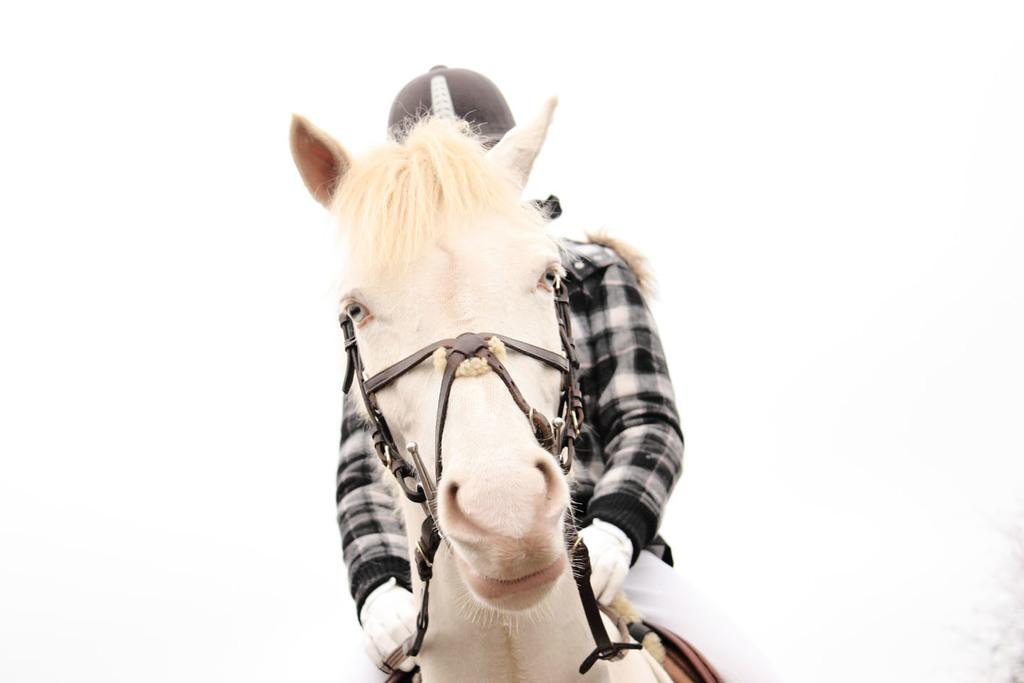What is the main subject of the image? There is a person in the image. What is the person doing in the image? The person is riding a horse. What type of industry can be seen in the background of the image? There is no industry present in the image; it features a person riding a horse. What role does the person play in the ongoing war in the image? There is no war present in the image, and therefore no role for the person to play. 